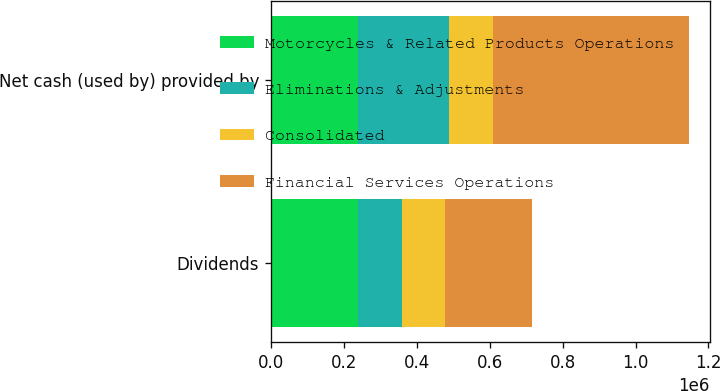<chart> <loc_0><loc_0><loc_500><loc_500><stacked_bar_chart><ecel><fcel>Dividends<fcel>Net cash (used by) provided by<nl><fcel>Motorcycles & Related Products Operations<fcel>238300<fcel>238300<nl><fcel>Eliminations & Adjustments<fcel>120000<fcel>251481<nl><fcel>Consolidated<fcel>120000<fcel>120000<nl><fcel>Financial Services Operations<fcel>238300<fcel>536096<nl></chart> 